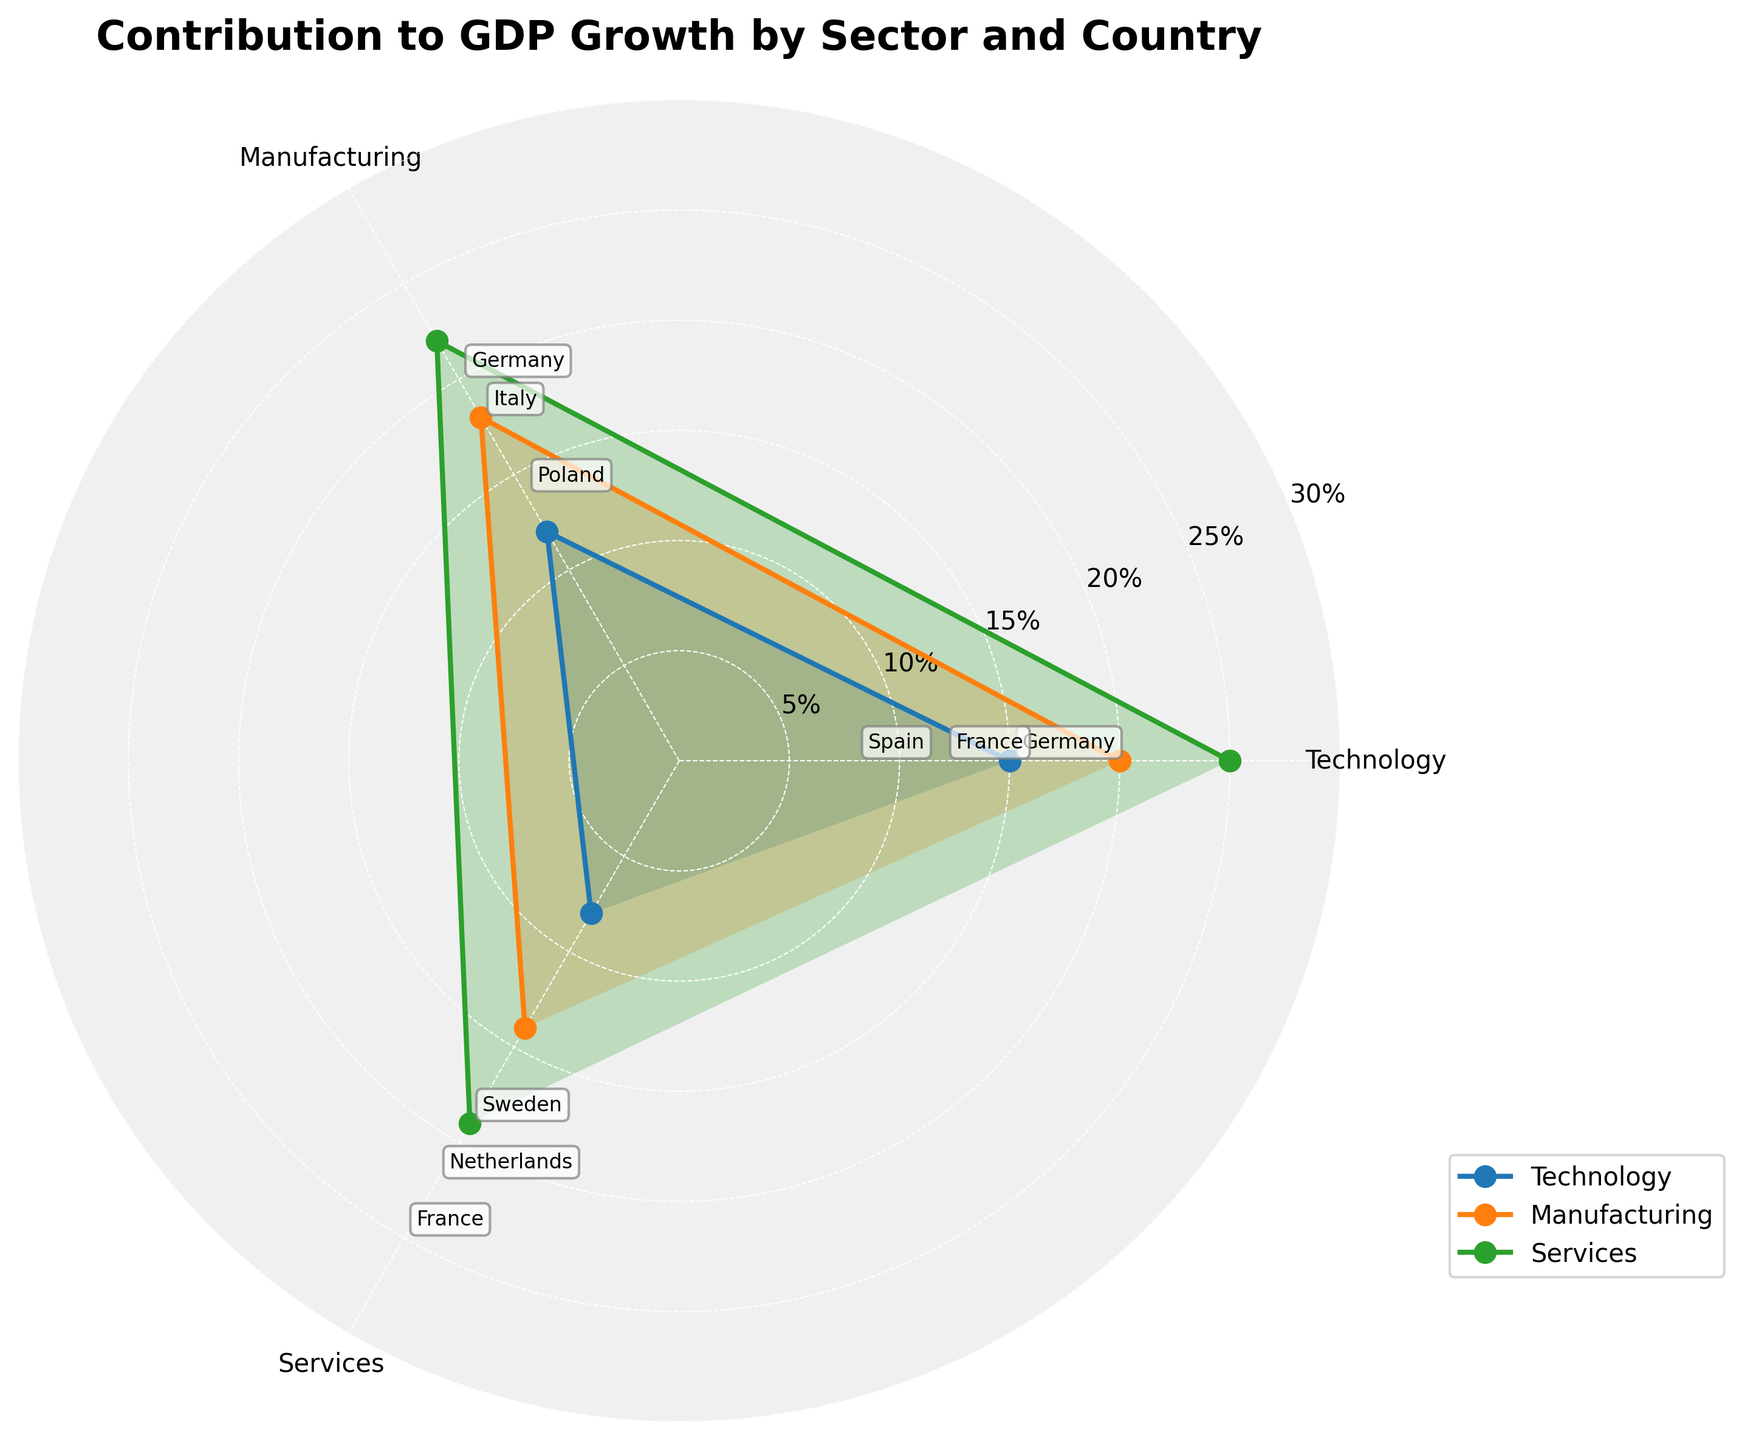Which country has the highest contribution to GDP growth in the services sector? To find the highest contribution to GDP growth in the services sector, locate the values corresponding to the services sector in the rose chart and identify the highest data point. The chart shows that France has the highest contribution of 25%.
Answer: France Which sector overall contributes the most to GDP growth in Germany? Locate the sectors (Technology and Manufacturing) and their respective contributions to GDP growth for Germany on the rose chart. Manufacturing has the higher value with 20% compared to Technology's 15%.
Answer: Manufacturing What is the difference in GDP growth contribution between the manufacturing sectors of Italy and Poland? Identify the contributions of Manufacturing sectors in Italy and Poland from the rose chart. Subtract the contribution of Poland (14%) from the contribution of Italy (18%).
Answer: 4% Which sector sees the largest variation in contribution to GDP growth among the countries listed? Assess the range of values for each sector in the rose chart. Technology ranges from 8% to 15%, Manufacturing ranges from 14% to 20%, and Services ranges from 19% to 25%. The largest range is observed in Services (6%).
Answer: Services Compare the average contributions to GDP growth of the services sector and the technology sector. Which is higher? Calculate the average for each sector. Services: (25+22+19)/3 = 22%. Technology: (15+12+8)/3 ≈ 11.67%. Services has the higher average contribution.
Answer: Services What are the three countries contributing to GDP growth in the technology sector? Identify the countries listed under the technology sector in the rose chart. The countries are Germany, France, and Spain.
Answer: Germany, France, and Spain Which country has the lowest contribution to GDP growth in the technology sector? Look at the contributions of the technology sector for all listed countries in the rose chart. Spain has the lowest contribution with 8%.
Answer: Spain What are the contributions to GDP growth of the manufacturing sector in Germany, Italy, and Poland summed together? Sum the contributions for these countries from the manufacturing sector: 20% (Germany) + 18% (Italy) + 14% (Poland) = 52%.
Answer: 52% Which sector exhibits the highest single country's contribution to GDP growth in the entire chart? Identify the highest contribution value across all sectors for any single country listed in the rose chart. France's services sector has the highest value of 25%.
Answer: Services in France 